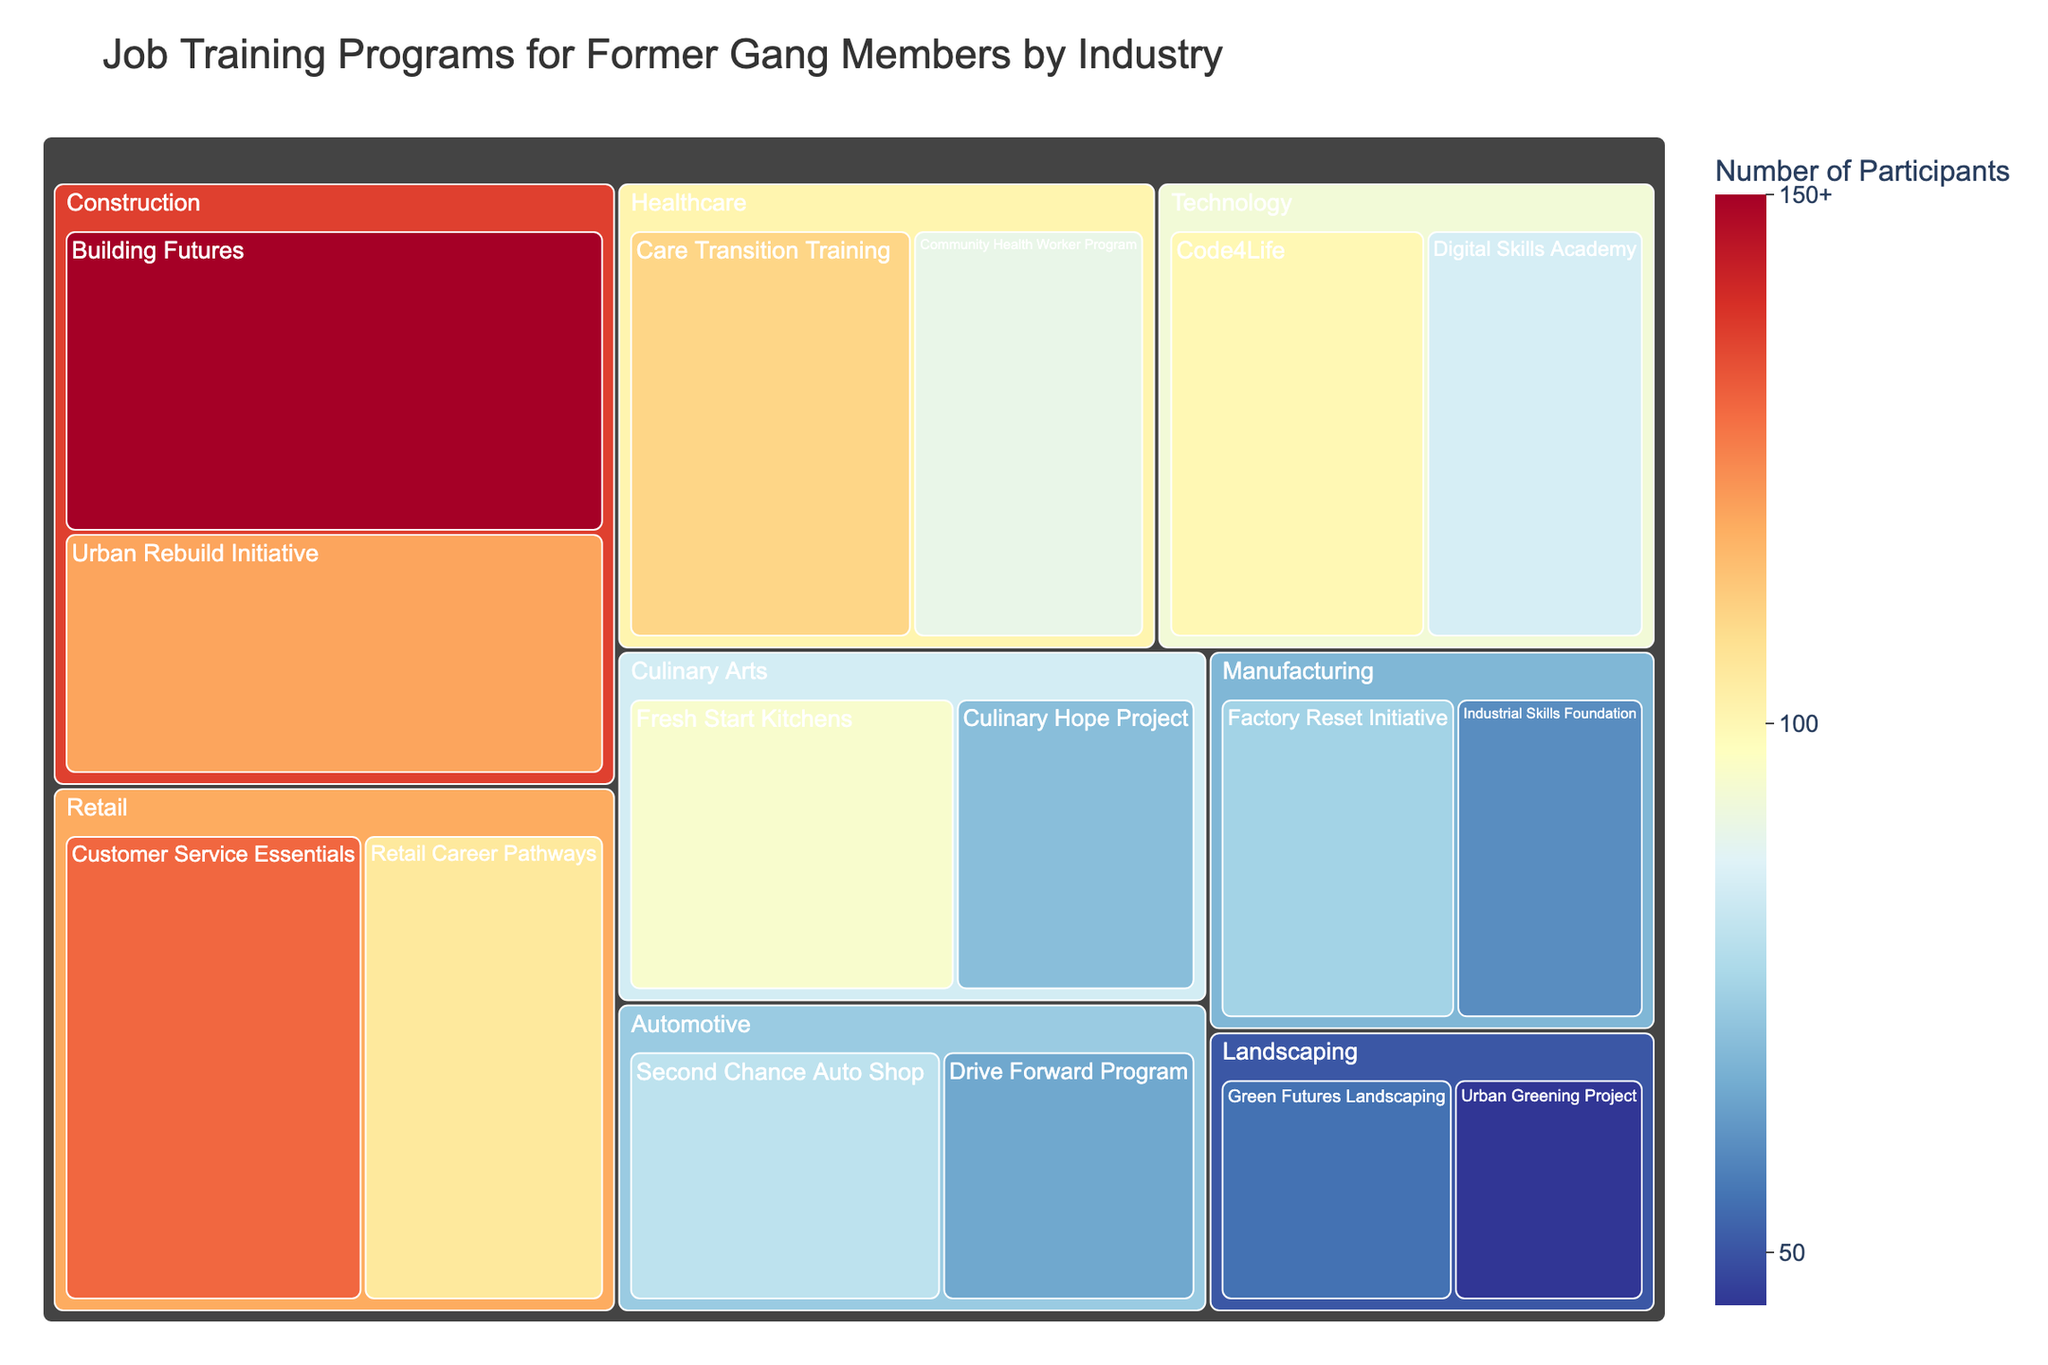Which industry has the highest number of participants in job training programs? By examining the tree map, the Construction industry has the largest tiles, indicating it has the highest number of participants. Summing up the participants from the two Construction programs, Building Futures (150) and Urban Rebuild Initiative (120), gives 270 participants.
Answer: Construction Which program has the least number of participants? By looking at the smallest tile in the treemap, the Urban Greening Project in the Landscaping industry has the smallest box, indicating it has the fewest participants (45).
Answer: Urban Greening Project How many participants are there in the Healthcare industry? Summing up the participants in the Healthcare industry: Care Transition Training (110) and Community Health Worker Program (90), results in 200 participants.
Answer: 200 Which industry has more participants, Technology or Healthcare? By comparing the sizes of the tiles for the Technology and Healthcare industries: Technology has Code4Life (100) and Digital Skills Academy (85) for a total of 185 participants, whereas Healthcare has Care Transition Training (110) and Community Health Worker Program (90) for a total of 200 participants. Thus, Healthcare has more participants.
Answer: Healthcare What is the difference in the number of participants between the largest and smallest programs in Construction? The largest program in Construction is Building Futures with 150 participants, and the smallest is Urban Rebuild Initiative with 120 participants. The difference is 150 - 120 = 30 participants.
Answer: 30 What is the average number of participants across all Retail programs? Summing the participants in the Retail industry: Customer Service Essentials (130) and Retail Career Pathways (105) gives 235 participants. Dividing by the number of Retail programs (2) results in an average of 235 / 2 = 117.5 participants.
Answer: 117.5 How many programs are available in the Manufacturing industry, and what is their combined number of participants? According to the figure, there are two programs in Manufacturing: Factory Reset Initiative (75) and Industrial Skills Foundation (60). Adding the participants together, 75 + 60 results in 135 participants.
Answer: 2 programs, 135 participants Which program in the Automotive industry has more participants, and by how much? Comparing the two programs in the Automotive industry: Second Chance Auto Shop (80) and Drive Forward Program (65), the Second Chance Auto Shop has more participants. The difference is 80 - 65 = 15 participants.
Answer: Second Chance Auto Shop, 15 participants What is the combined number of participants in Landscaping and Culinary Arts industries? Summing the participants in the Landscaping industry: Green Futures Landscaping (55) and Urban Greening Project (45) gives 100. Summing the participants in the Culinary Arts industry: Fresh Start Kitchens (95) and Culinary Hope Project (70) gives 165. Adding both totals results in 100 + 165 = 265 participants.
Answer: 265 Which industry has fewer participants, Automotive or Manufacturing? Adding the participants in Automotive: Second Chance Auto Shop (80) and Drive Forward Program (65) results in 145 participants. Adding the participants in Manufacturing: Factory Reset Initiative (75) and Industrial Skills Foundation (60) results in 135 participants. Therefore, Manufacturing has fewer participants.
Answer: Manufacturing 